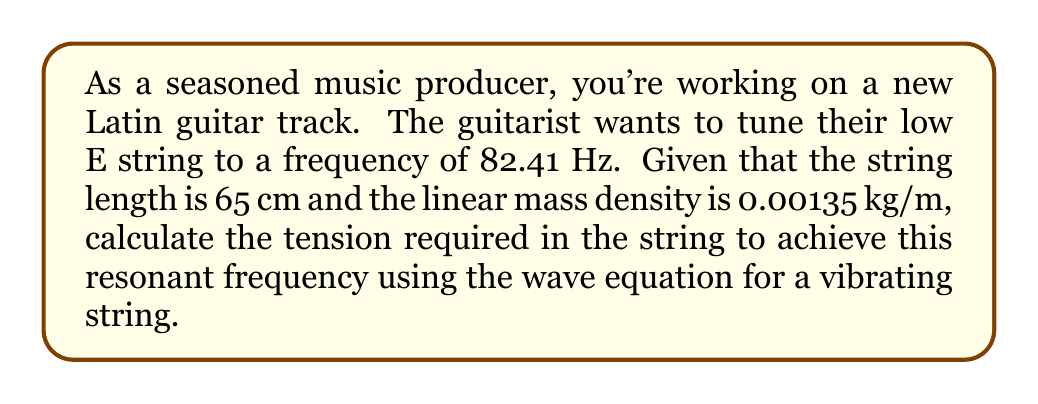Could you help me with this problem? To solve this problem, we'll use the wave equation for a vibrating string:

$$f = \frac{1}{2L}\sqrt{\frac{T}{\mu}}$$

Where:
$f$ = resonant frequency (Hz)
$L$ = length of the string (m)
$T$ = tension in the string (N)
$\mu$ = linear mass density (kg/m)

Given:
$f = 82.41$ Hz
$L = 65$ cm $= 0.65$ m
$\mu = 0.00135$ kg/m

Step 1: Rearrange the equation to solve for $T$:
$$T = 4L^2f^2\mu$$

Step 2: Substitute the known values:
$$T = 4 \cdot (0.65\text{ m})^2 \cdot (82.41\text{ Hz})^2 \cdot (0.00135\text{ kg/m})$$

Step 3: Calculate the result:
$$T = 4 \cdot 0.4225 \cdot 6791.4081 \cdot 0.00135$$
$$T = 15.5029\text{ N}$$

Therefore, the tension required in the string to achieve a resonant frequency of 82.41 Hz is approximately 15.50 N.
Answer: $15.50\text{ N}$ 